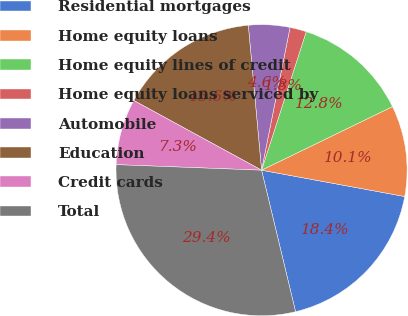Convert chart. <chart><loc_0><loc_0><loc_500><loc_500><pie_chart><fcel>Residential mortgages<fcel>Home equity loans<fcel>Home equity lines of credit<fcel>Home equity loans serviced by<fcel>Automobile<fcel>Education<fcel>Credit cards<fcel>Total<nl><fcel>18.35%<fcel>10.09%<fcel>12.84%<fcel>1.83%<fcel>4.59%<fcel>15.6%<fcel>7.34%<fcel>29.36%<nl></chart> 